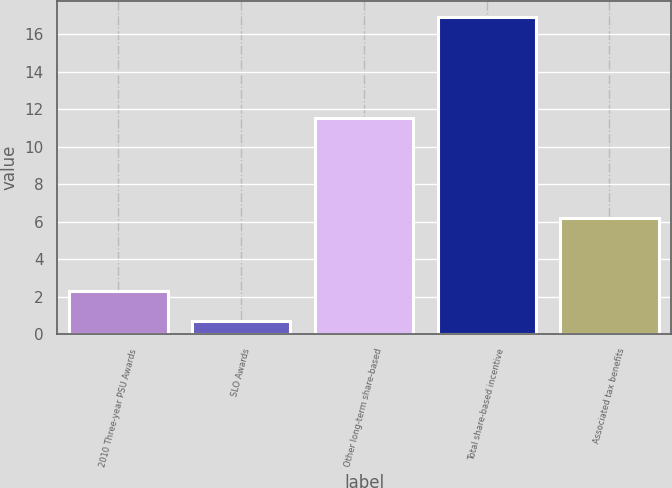<chart> <loc_0><loc_0><loc_500><loc_500><bar_chart><fcel>2010 Three-year PSU Awards<fcel>SLO Awards<fcel>Other long-term share-based<fcel>Total share-based incentive<fcel>Associated tax benefits<nl><fcel>2.32<fcel>0.7<fcel>11.5<fcel>16.9<fcel>6.2<nl></chart> 